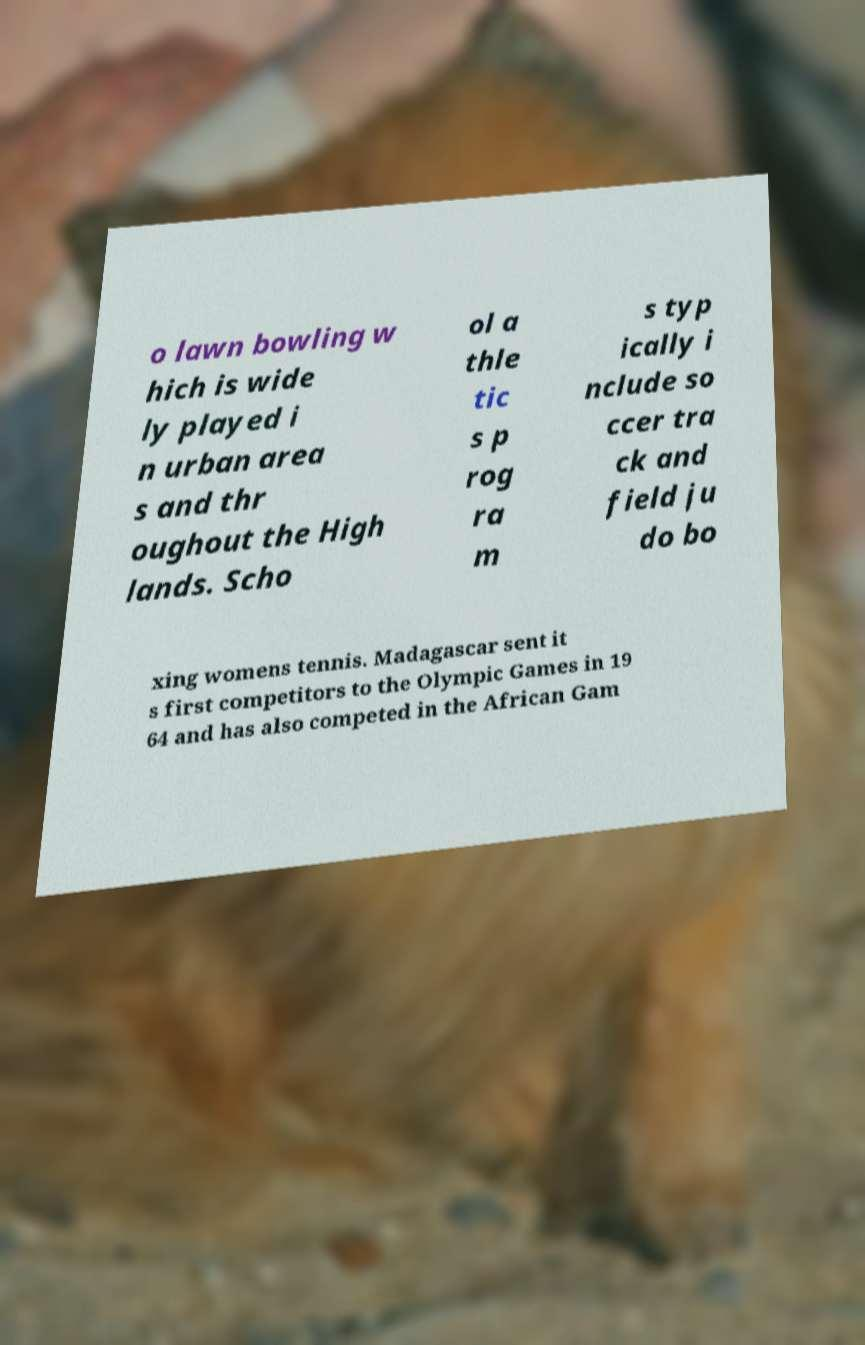Could you assist in decoding the text presented in this image and type it out clearly? o lawn bowling w hich is wide ly played i n urban area s and thr oughout the High lands. Scho ol a thle tic s p rog ra m s typ ically i nclude so ccer tra ck and field ju do bo xing womens tennis. Madagascar sent it s first competitors to the Olympic Games in 19 64 and has also competed in the African Gam 